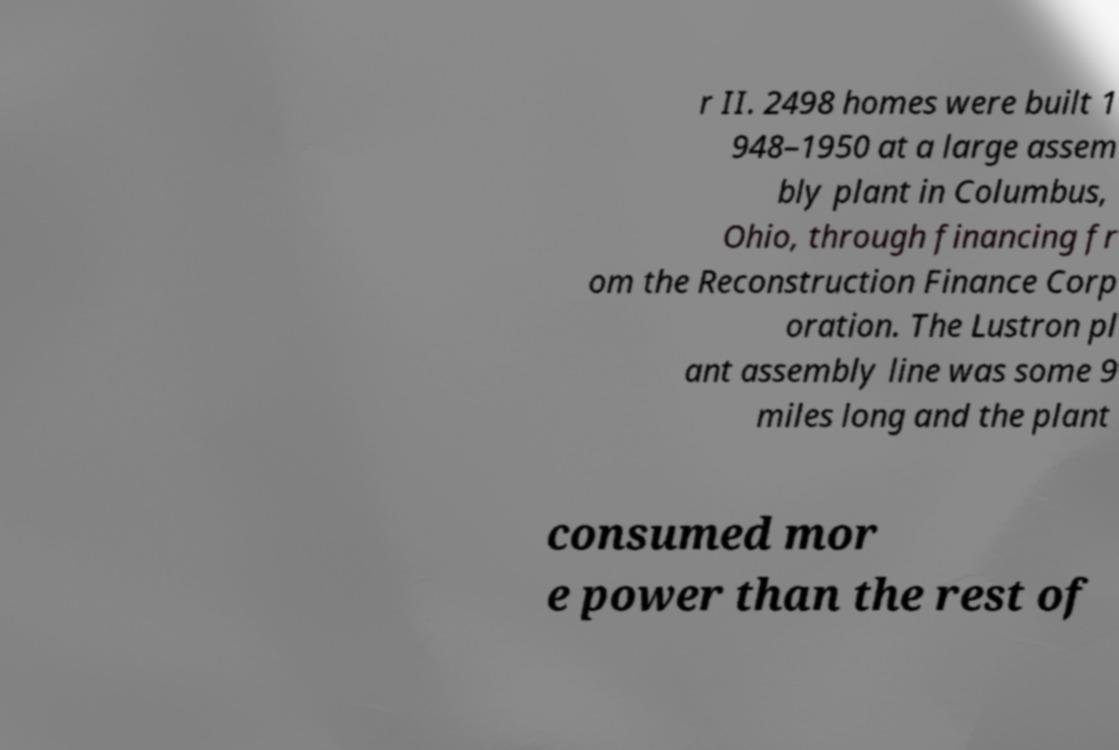What messages or text are displayed in this image? I need them in a readable, typed format. r II. 2498 homes were built 1 948–1950 at a large assem bly plant in Columbus, Ohio, through financing fr om the Reconstruction Finance Corp oration. The Lustron pl ant assembly line was some 9 miles long and the plant consumed mor e power than the rest of 